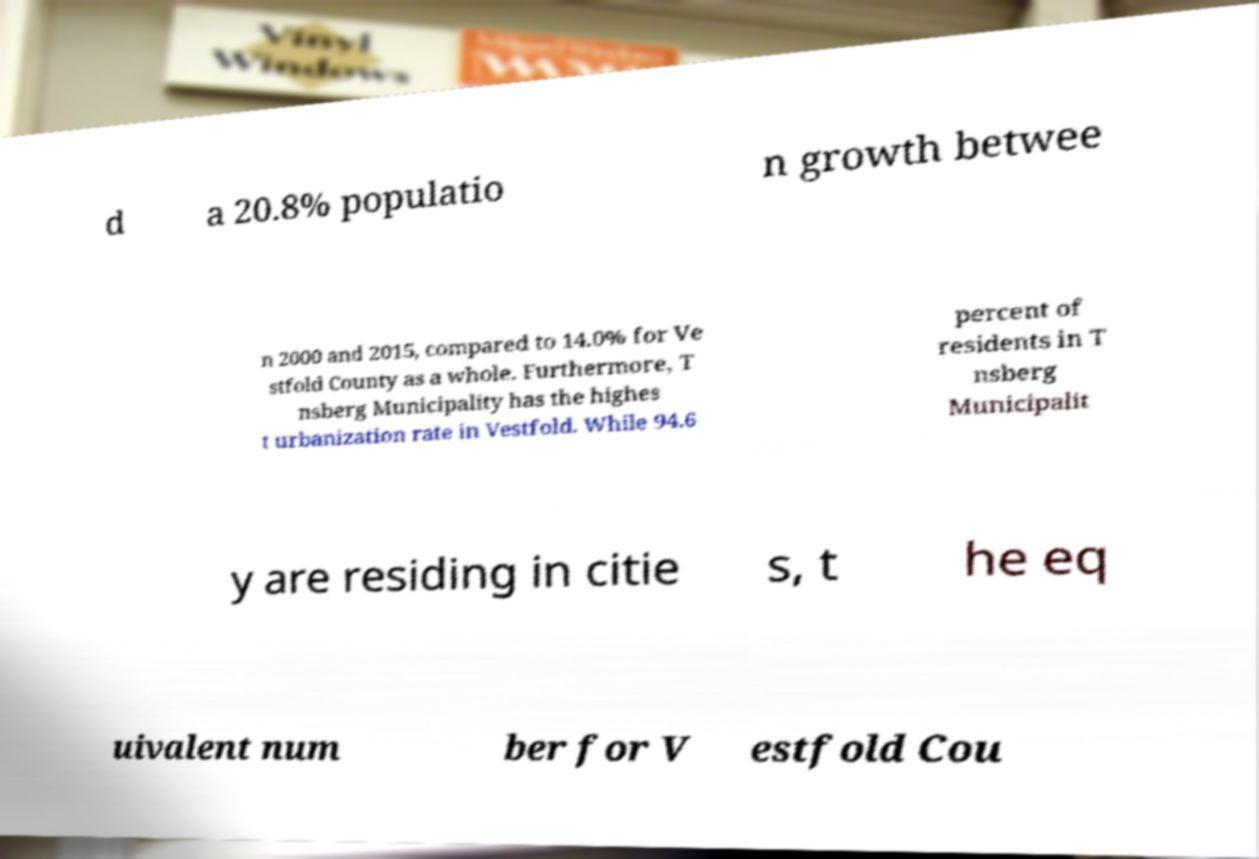For documentation purposes, I need the text within this image transcribed. Could you provide that? d a 20.8% populatio n growth betwee n 2000 and 2015, compared to 14.0% for Ve stfold County as a whole. Furthermore, T nsberg Municipality has the highes t urbanization rate in Vestfold. While 94.6 percent of residents in T nsberg Municipalit y are residing in citie s, t he eq uivalent num ber for V estfold Cou 